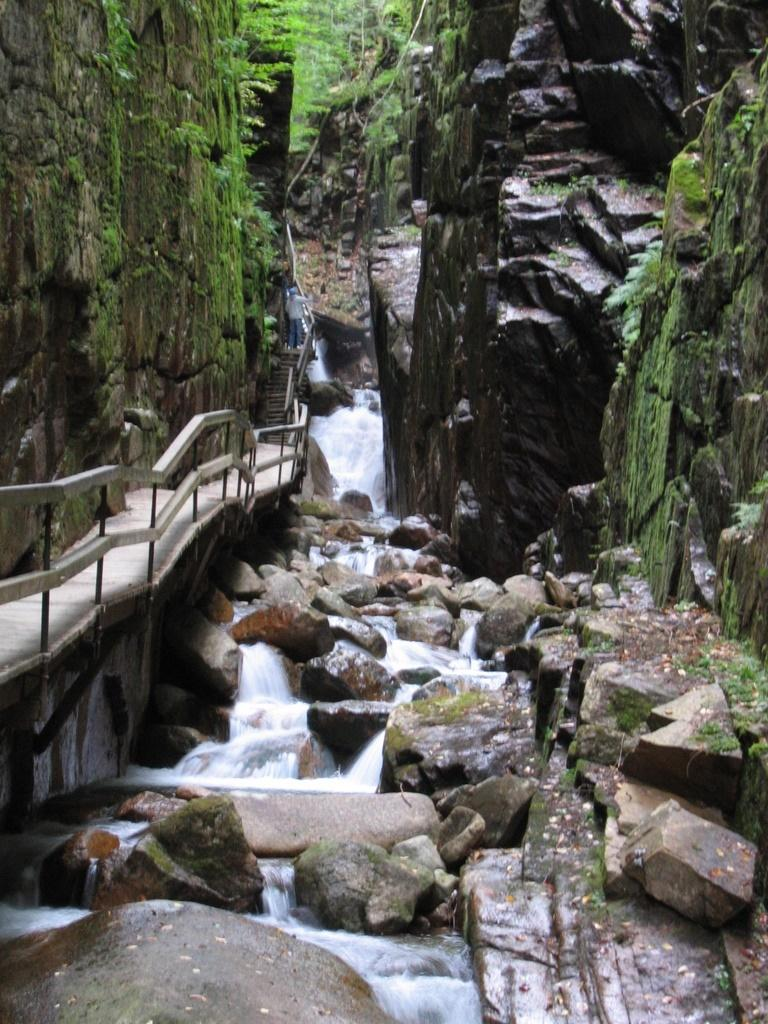What natural feature is the main subject of the image? There is a waterfall in the image. What can be seen in the background behind the waterfall? In the background, there are stones, a bridge, and trees with green color. Can you describe the type of vegetation present in the image? The trees in the background have green color, indicating that they are likely alive and healthy. How does the image convey a sense of the environment? By describing the waterfall, stones, bridge, and trees, we provide a comprehensive overview of the natural environment depicted in the image. We avoid yes/no questions and ensure that the language is simple and clear. Absurd Question/Answer: What type of bead is being used by the laborer in the image? There is no laborer or bead present in the image. The image features a waterfall, stones, a bridge, and trees with green color. What time of day is it in the image, given the presence of the afternoon sun? There is no mention of the sun or time of day in the image. The image features a waterfall, stones, a bridge, and trees with green color. 